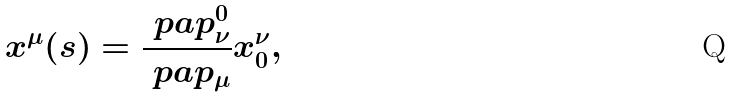Convert formula to latex. <formula><loc_0><loc_0><loc_500><loc_500>x ^ { \mu } ( s ) = \frac { \ p a p ^ { 0 } _ { \nu } } { \ p a p _ { \mu } } x _ { 0 } ^ { \nu } ,</formula> 